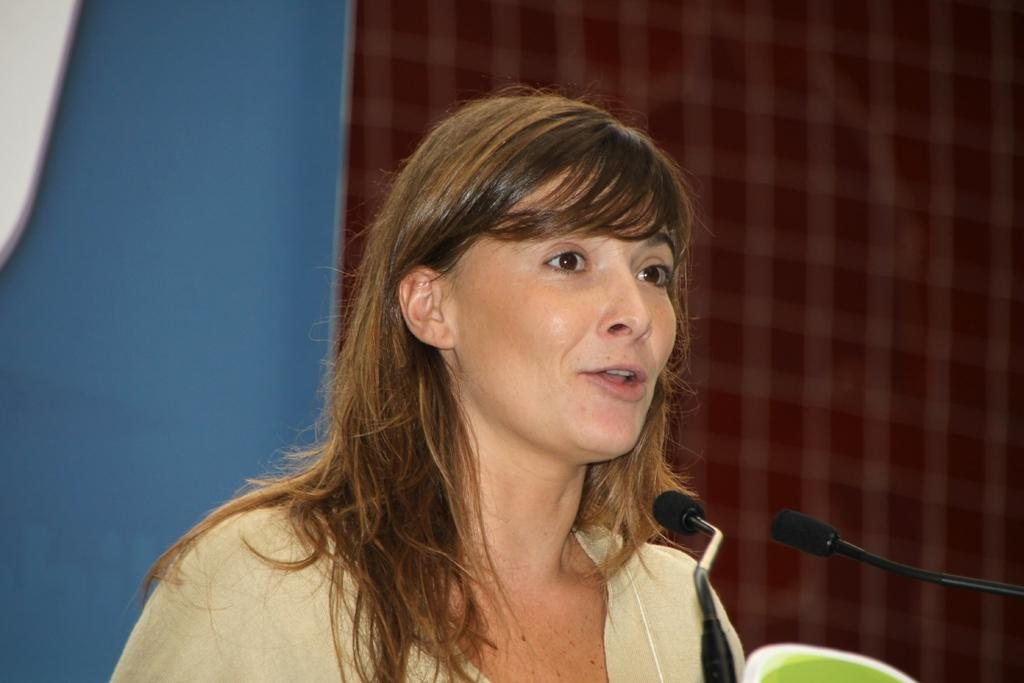Who is the main subject in the image? There is a woman in the center of the image. What is the woman doing in the image? The woman is speaking to a microphone. What can be seen in the background of the image? There is a curtain and a wall in the background of the image. What type of flowers can be seen growing near the woman in the image? There are no flowers visible in the image. Can you describe the yak that is standing next to the woman in the image? There is no yak present in the image; the main subject is a woman speaking to a microphone. 